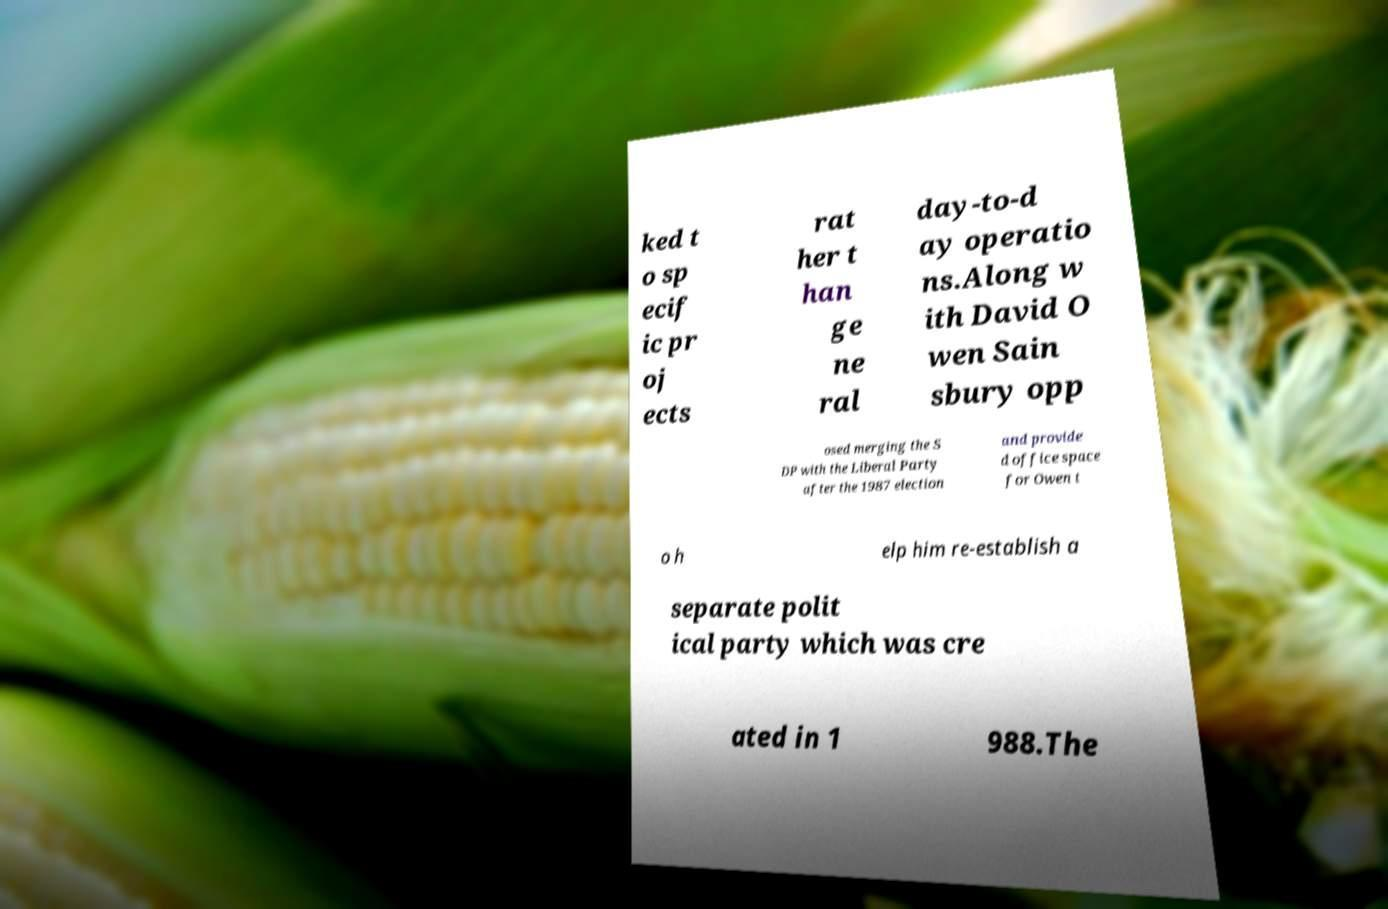Could you assist in decoding the text presented in this image and type it out clearly? ked t o sp ecif ic pr oj ects rat her t han ge ne ral day-to-d ay operatio ns.Along w ith David O wen Sain sbury opp osed merging the S DP with the Liberal Party after the 1987 election and provide d office space for Owen t o h elp him re-establish a separate polit ical party which was cre ated in 1 988.The 